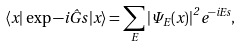Convert formula to latex. <formula><loc_0><loc_0><loc_500><loc_500>\langle x | \, \exp { - i { \hat { G } } s } \, | x \rangle = \sum _ { E } { | \Psi _ { E } ( x ) | } ^ { 2 } \, e ^ { - i E s } ,</formula> 